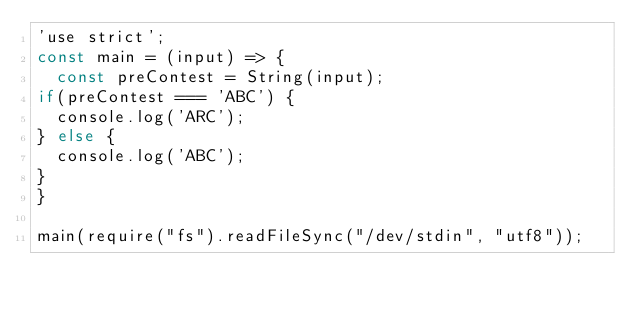Convert code to text. <code><loc_0><loc_0><loc_500><loc_500><_JavaScript_>'use strict';
const main = (input) => {
  const preContest = String(input);
if(preContest === 'ABC') {
  console.log('ARC');
} else {
  console.log('ABC');
}
}

main(require("fs").readFileSync("/dev/stdin", "utf8"));</code> 